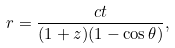Convert formula to latex. <formula><loc_0><loc_0><loc_500><loc_500>r = \frac { c t } { ( 1 + z ) ( 1 - \cos \theta ) } ,</formula> 